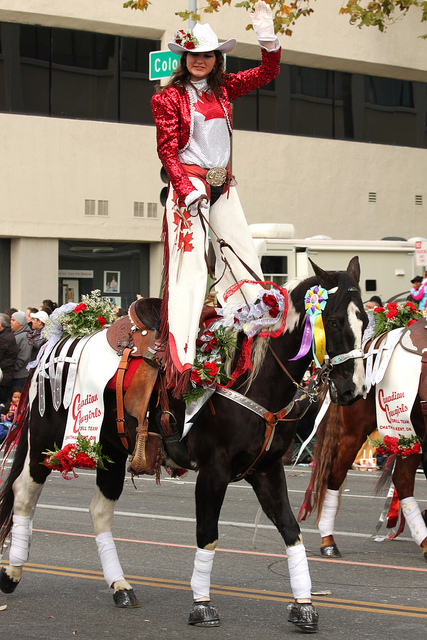How many boats are in the water? There are no boats visible in the image; instead, it depicts a person riding a decorated horse with what appears to be a parade or festival setting in the background. 